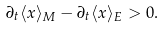Convert formula to latex. <formula><loc_0><loc_0><loc_500><loc_500>\partial _ { t } \langle x \rangle _ { M } - \partial _ { t } \langle x \rangle _ { E } > 0 .</formula> 